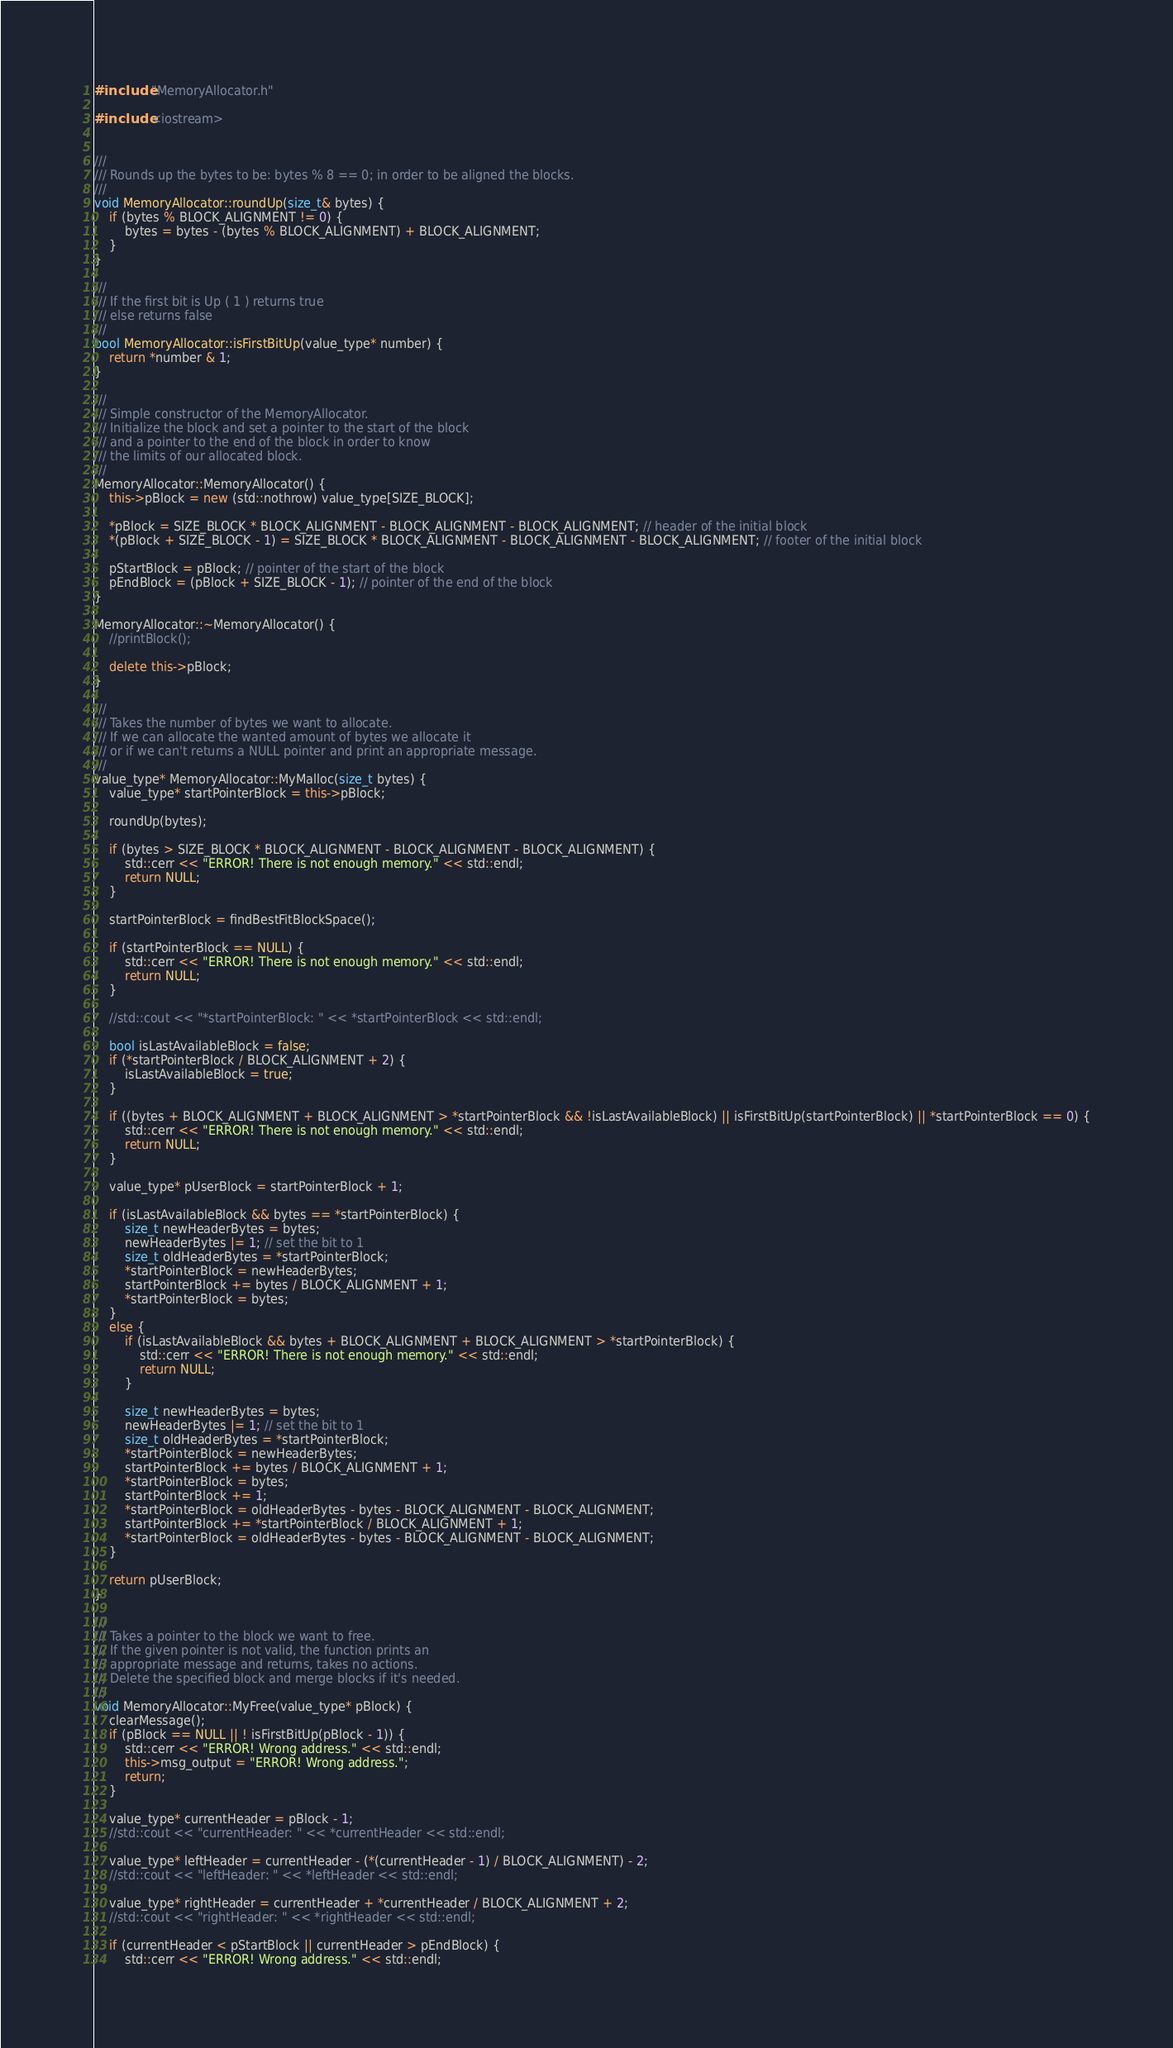Convert code to text. <code><loc_0><loc_0><loc_500><loc_500><_C++_>#include "MemoryAllocator.h"

#include <iostream>


///
/// Rounds up the bytes to be: bytes % 8 == 0; in order to be aligned the blocks.
///
void MemoryAllocator::roundUp(size_t& bytes) {
	if (bytes % BLOCK_ALIGNMENT != 0) {
		bytes = bytes - (bytes % BLOCK_ALIGNMENT) + BLOCK_ALIGNMENT;
	}
}

///
/// If the first bit is Up ( 1 ) returns true
/// else returns false
///
bool MemoryAllocator::isFirstBitUp(value_type* number) {
	return *number & 1;
}

///
/// Simple constructor of the MemoryAllocator.
/// Initialize the block and set a pointer to the start of the block
/// and a pointer to the end of the block in order to know
/// the limits of our allocated block.
///
MemoryAllocator::MemoryAllocator() {
	this->pBlock = new (std::nothrow) value_type[SIZE_BLOCK];

	*pBlock = SIZE_BLOCK * BLOCK_ALIGNMENT - BLOCK_ALIGNMENT - BLOCK_ALIGNMENT; // header of the initial block
	*(pBlock + SIZE_BLOCK - 1) = SIZE_BLOCK * BLOCK_ALIGNMENT - BLOCK_ALIGNMENT - BLOCK_ALIGNMENT; // footer of the initial block

	pStartBlock = pBlock; // pointer of the start of the block
	pEndBlock = (pBlock + SIZE_BLOCK - 1); // pointer of the end of the block
}

MemoryAllocator::~MemoryAllocator() {
	//printBlock();

	delete this->pBlock;
}

///
/// Takes the number of bytes we want to allocate.
/// If we can allocate the wanted amount of bytes we allocate it
/// or if we can't returns a NULL pointer and print an appropriate message.
///
value_type* MemoryAllocator::MyMalloc(size_t bytes) {
	value_type* startPointerBlock = this->pBlock;
	
	roundUp(bytes);

	if (bytes > SIZE_BLOCK * BLOCK_ALIGNMENT - BLOCK_ALIGNMENT - BLOCK_ALIGNMENT) {
		std::cerr << "ERROR! There is not enough memory." << std::endl;
		return NULL;
	}

	startPointerBlock = findBestFitBlockSpace();

	if (startPointerBlock == NULL) {
		std::cerr << "ERROR! There is not enough memory." << std::endl;
		return NULL;
	}

	//std::cout << "*startPointerBlock: " << *startPointerBlock << std::endl;

	bool isLastAvailableBlock = false;
	if (*startPointerBlock / BLOCK_ALIGNMENT + 2) {
		isLastAvailableBlock = true;
	}

	if ((bytes + BLOCK_ALIGNMENT + BLOCK_ALIGNMENT > *startPointerBlock && !isLastAvailableBlock) || isFirstBitUp(startPointerBlock) || *startPointerBlock == 0) {
		std::cerr << "ERROR! There is not enough memory." << std::endl;
		return NULL;
	}

	value_type* pUserBlock = startPointerBlock + 1;
			
	if (isLastAvailableBlock && bytes == *startPointerBlock) {
		size_t newHeaderBytes = bytes;
		newHeaderBytes |= 1; // set the bit to 1
		size_t oldHeaderBytes = *startPointerBlock;
		*startPointerBlock = newHeaderBytes;
		startPointerBlock += bytes / BLOCK_ALIGNMENT + 1;
		*startPointerBlock = bytes;
	}
	else {
		if (isLastAvailableBlock && bytes + BLOCK_ALIGNMENT + BLOCK_ALIGNMENT > *startPointerBlock) {
			std::cerr << "ERROR! There is not enough memory." << std::endl;
			return NULL;
		}

		size_t newHeaderBytes = bytes;
		newHeaderBytes |= 1; // set the bit to 1
		size_t oldHeaderBytes = *startPointerBlock;
		*startPointerBlock = newHeaderBytes;
		startPointerBlock += bytes / BLOCK_ALIGNMENT + 1;
		*startPointerBlock = bytes;
		startPointerBlock += 1;
		*startPointerBlock = oldHeaderBytes - bytes - BLOCK_ALIGNMENT - BLOCK_ALIGNMENT;
		startPointerBlock += *startPointerBlock / BLOCK_ALIGNMENT + 1;
		*startPointerBlock = oldHeaderBytes - bytes - BLOCK_ALIGNMENT - BLOCK_ALIGNMENT;
	}
		
	return pUserBlock;
}

///
/// Takes a pointer to the block we want to free.
/// If the given pointer is not valid, the function prints an
/// appropriate message and returns, takes no actions.
/// Delete the specified block and merge blocks if it's needed.
///
void MemoryAllocator::MyFree(value_type* pBlock) {
	clearMessage();
	if (pBlock == NULL || ! isFirstBitUp(pBlock - 1)) {
		std::cerr << "ERROR! Wrong address." << std::endl;
		this->msg_output = "ERROR! Wrong address.";
		return;
	}

	value_type* currentHeader = pBlock - 1; 
	//std::cout << "currentHeader: " << *currentHeader << std::endl;
	
	value_type* leftHeader = currentHeader - (*(currentHeader - 1) / BLOCK_ALIGNMENT) - 2;
	//std::cout << "leftHeader: " << *leftHeader << std::endl;
	
	value_type* rightHeader = currentHeader + *currentHeader / BLOCK_ALIGNMENT + 2;
	//std::cout << "rightHeader: " << *rightHeader << std::endl;

	if (currentHeader < pStartBlock || currentHeader > pEndBlock) {
		std::cerr << "ERROR! Wrong address." << std::endl;</code> 